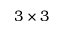Convert formula to latex. <formula><loc_0><loc_0><loc_500><loc_500>3 \times 3</formula> 